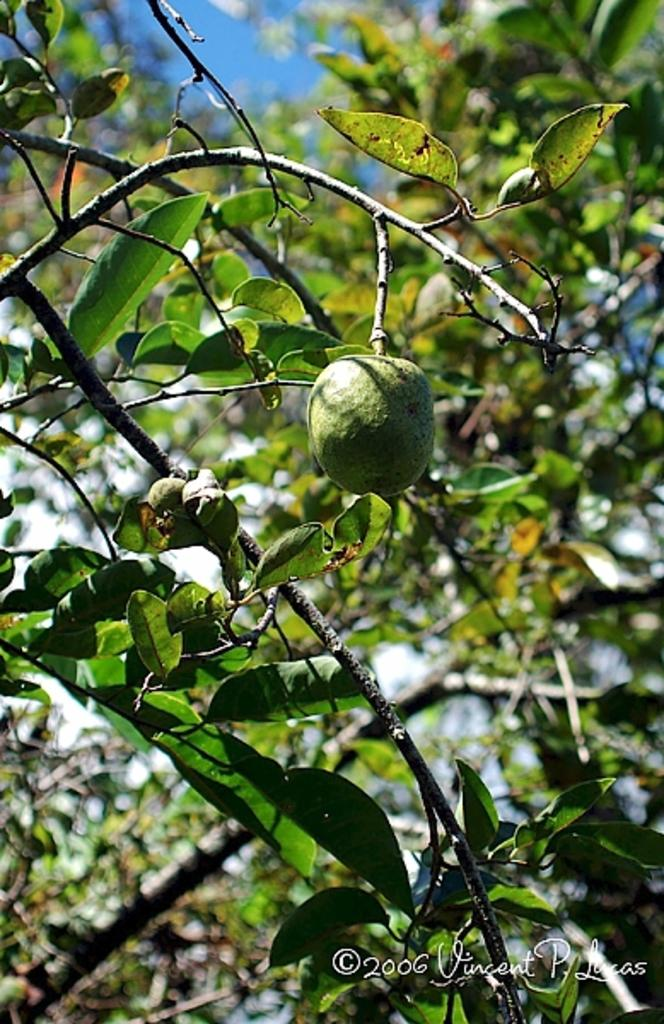What is on the branch of the tree in the image? There is a fruit on a branch of a tree in the image. What else can be seen in the background of the image? There are trees and the sky visible in the background of the image. How many people are jumping on the bed in the image? There are no people or beds present in the image. 